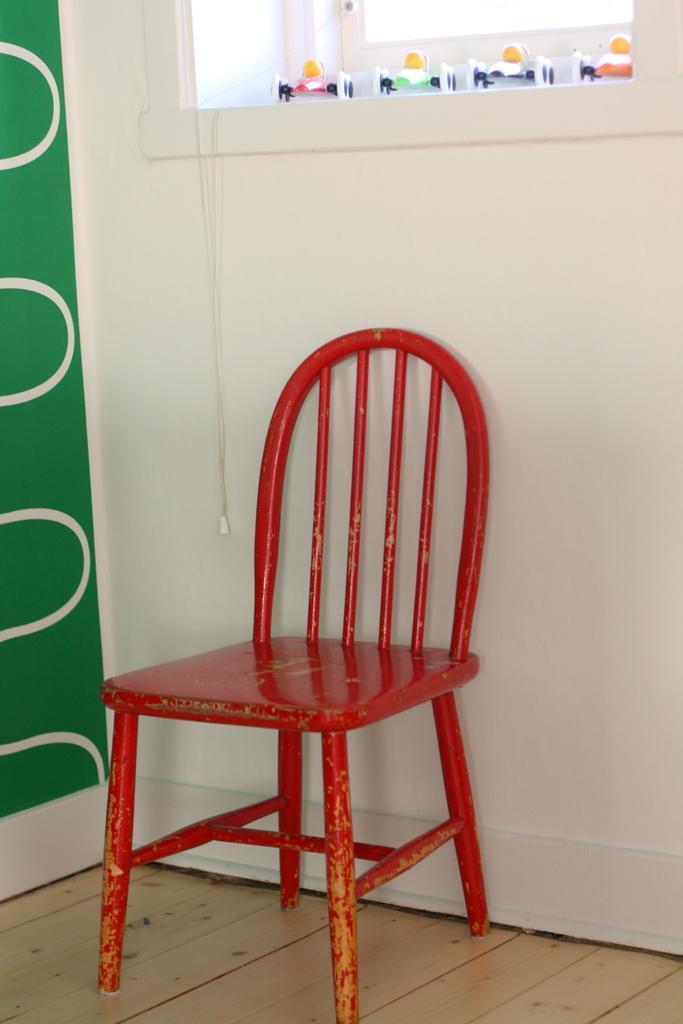How would you summarize this image in a sentence or two? In this picture we can see a chair, on the left side there is a wall, we can see a window at the top of the picture. 